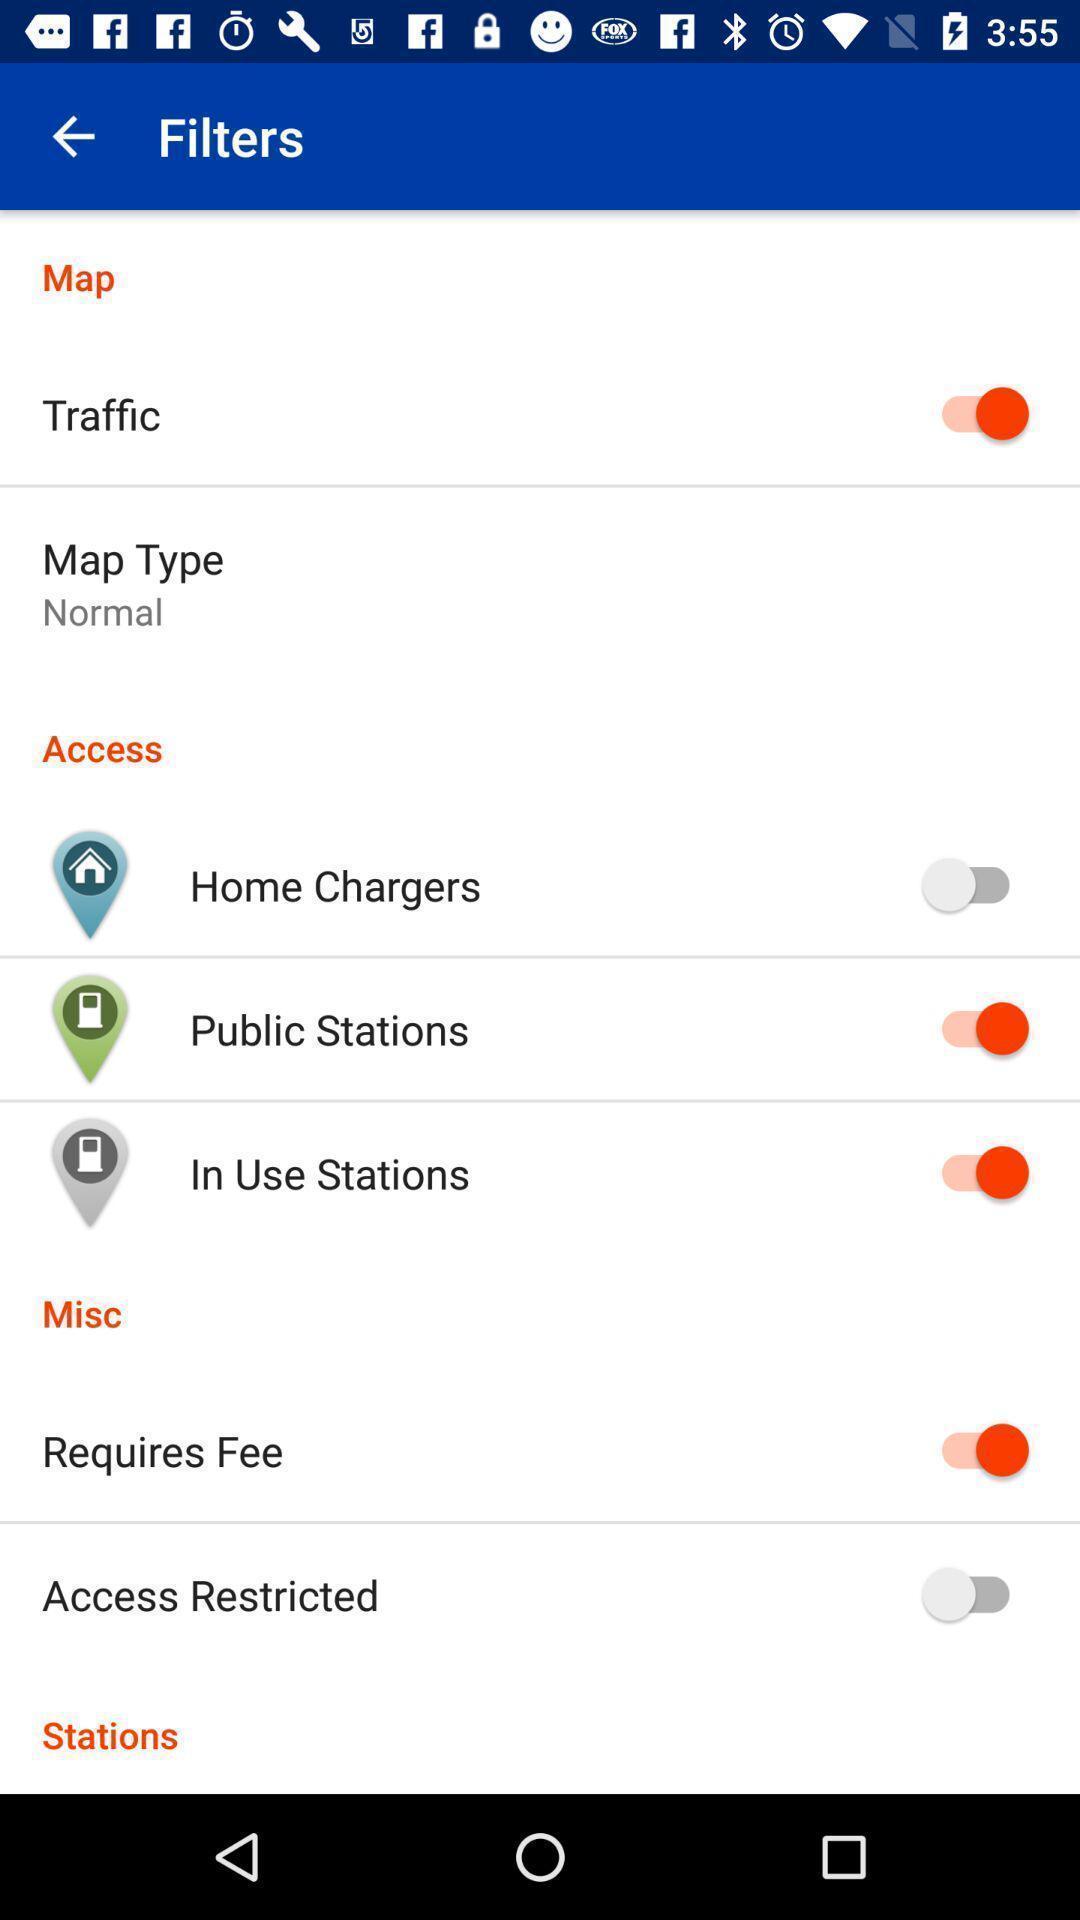Describe the content in this image. Settings menu for an electric charging station locator app. 